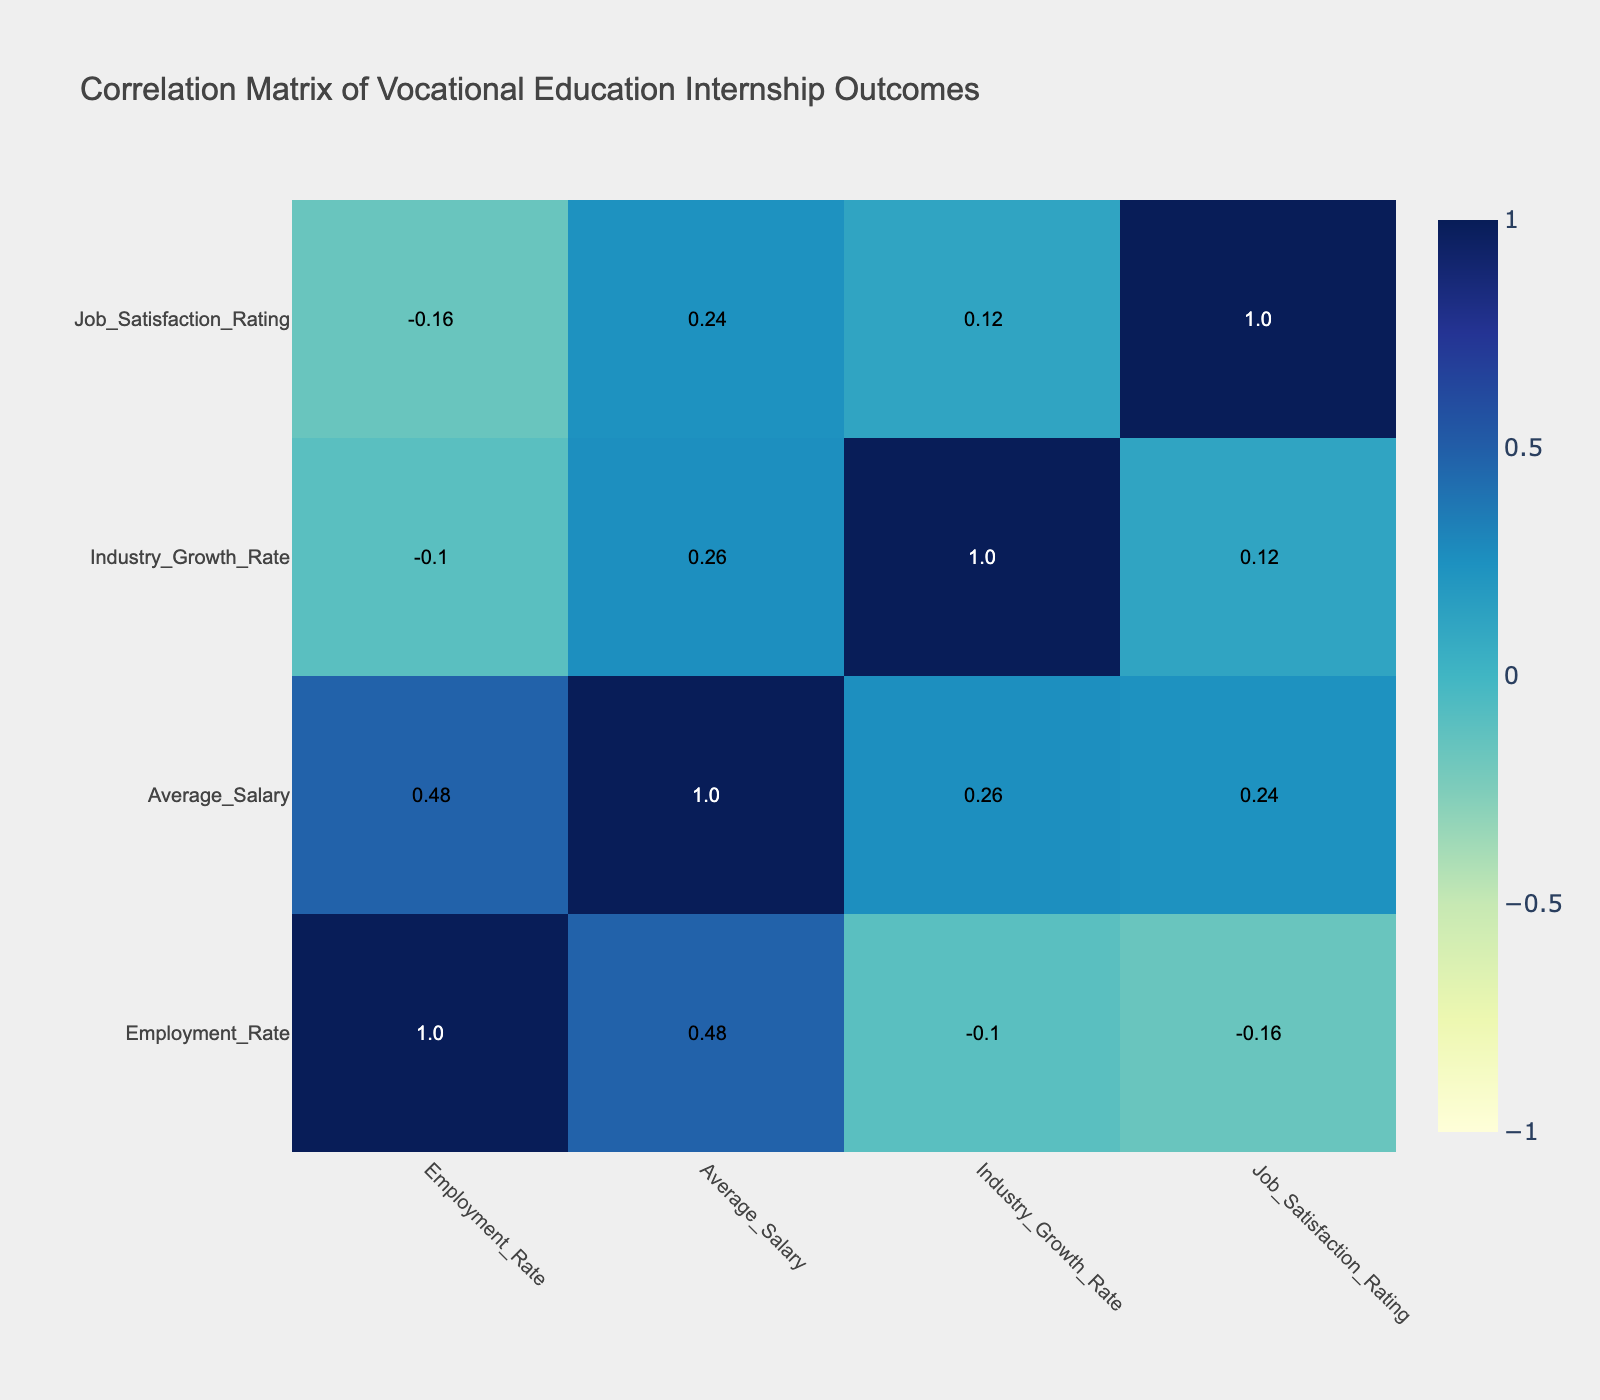What is the employment rate for the Welding Apprenticeship? The table shows that the employment rate for the Welding Apprenticeship is stated directly in the corresponding row, which is 90.
Answer: 90 What is the average salary for the Culinary Arts Internship? According to the table, the average salary for the Culinary Arts Internship is listed as 40000.
Answer: 40000 Which internship has the highest employment rate? By comparing all the employment rates listed in the table, the Construction Trades Internship has the highest rate at 92.
Answer: 92 Is the employment rate for Medical Assistant Internship above 75? Yes, the employment rate for the Medical Assistant Internship is 75, which is not above it but equals it. Thus, the answer is no.
Answer: No What is the difference in employment rates between the Automotive Technology Internship and the Medical Assistant Internship? The employment rate for the Automotive Technology Internship is 88 and for the Medical Assistant Internship is 75. The difference is calculated as 88 - 75 = 13.
Answer: 13 Which internship program has the lowest job satisfaction rating and what is the rating? Reviewing the job satisfaction ratings, the Construction Trades Internship has the lowest rating of 6.8.
Answer: 6.8 If we consider only the internships with an employment rate higher than 80, what is the average salary of these programs? The internships with an employment rate higher than 80 are: Welding Apprenticeship (50000), Automotive Technology Internship (48000), and Construction Trades Internship (52000). Summing these salaries, 50000 + 48000 + 52000 = 150000. There are three programs, so the average salary is 150000 / 3 = 50000.
Answer: 50000 True or False: The average salary for an internship with an employment rate below 80 is greater than 40000. The internships with an employment rate below 80 are the IT Technician Internship (60000), Medical Assistant Internship (35000), Graphic Design Internship (45000), and Pharmacy Technician Internship (37000). The average salary for these internships is (60000 + 35000 + 45000 + 37000) / 4 = 44250, which is greater than 40000.
Answer: True What is the correlation between Employment Rate and Average Salary based on the data provided? By examining the correlation matrix, the correlation value between Employment Rate and Average Salary appears to be positive. This means that a higher employment rate generally aligns with higher average salaries. The exact correlation calculated from the data is 0.56, indicating a moderate positive relationship.
Answer: 0.56 